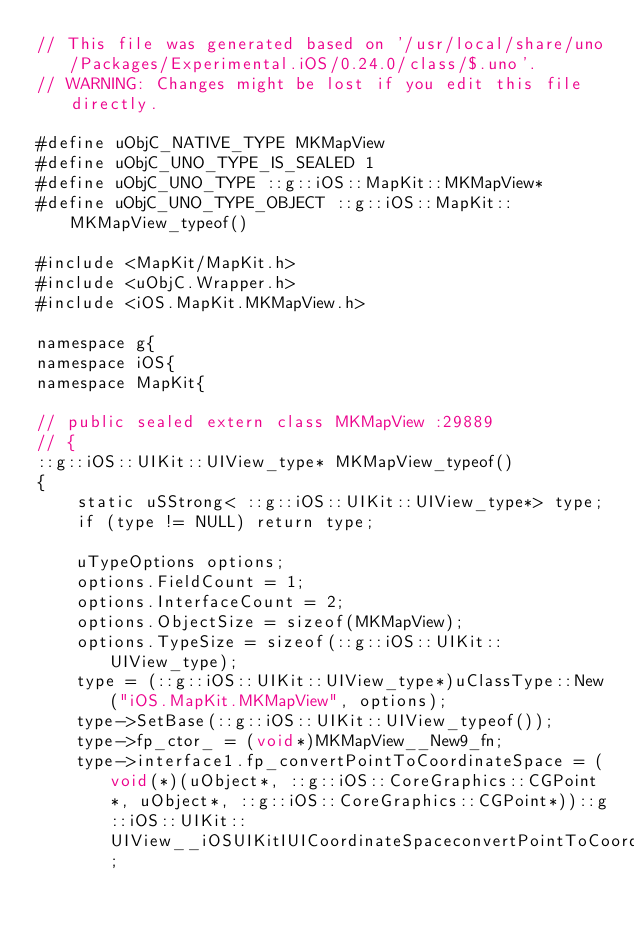Convert code to text. <code><loc_0><loc_0><loc_500><loc_500><_ObjectiveC_>// This file was generated based on '/usr/local/share/uno/Packages/Experimental.iOS/0.24.0/class/$.uno'.
// WARNING: Changes might be lost if you edit this file directly.

#define uObjC_NATIVE_TYPE MKMapView
#define uObjC_UNO_TYPE_IS_SEALED 1
#define uObjC_UNO_TYPE ::g::iOS::MapKit::MKMapView*
#define uObjC_UNO_TYPE_OBJECT ::g::iOS::MapKit::MKMapView_typeof()

#include <MapKit/MapKit.h>
#include <uObjC.Wrapper.h>
#include <iOS.MapKit.MKMapView.h>

namespace g{
namespace iOS{
namespace MapKit{

// public sealed extern class MKMapView :29889
// {
::g::iOS::UIKit::UIView_type* MKMapView_typeof()
{
    static uSStrong< ::g::iOS::UIKit::UIView_type*> type;
    if (type != NULL) return type;

    uTypeOptions options;
    options.FieldCount = 1;
    options.InterfaceCount = 2;
    options.ObjectSize = sizeof(MKMapView);
    options.TypeSize = sizeof(::g::iOS::UIKit::UIView_type);
    type = (::g::iOS::UIKit::UIView_type*)uClassType::New("iOS.MapKit.MKMapView", options);
    type->SetBase(::g::iOS::UIKit::UIView_typeof());
    type->fp_ctor_ = (void*)MKMapView__New9_fn;
    type->interface1.fp_convertPointToCoordinateSpace = (void(*)(uObject*, ::g::iOS::CoreGraphics::CGPoint*, uObject*, ::g::iOS::CoreGraphics::CGPoint*))::g::iOS::UIKit::UIView__iOSUIKitIUICoordinateSpaceconvertPointToCoordinateSpace_fn;</code> 